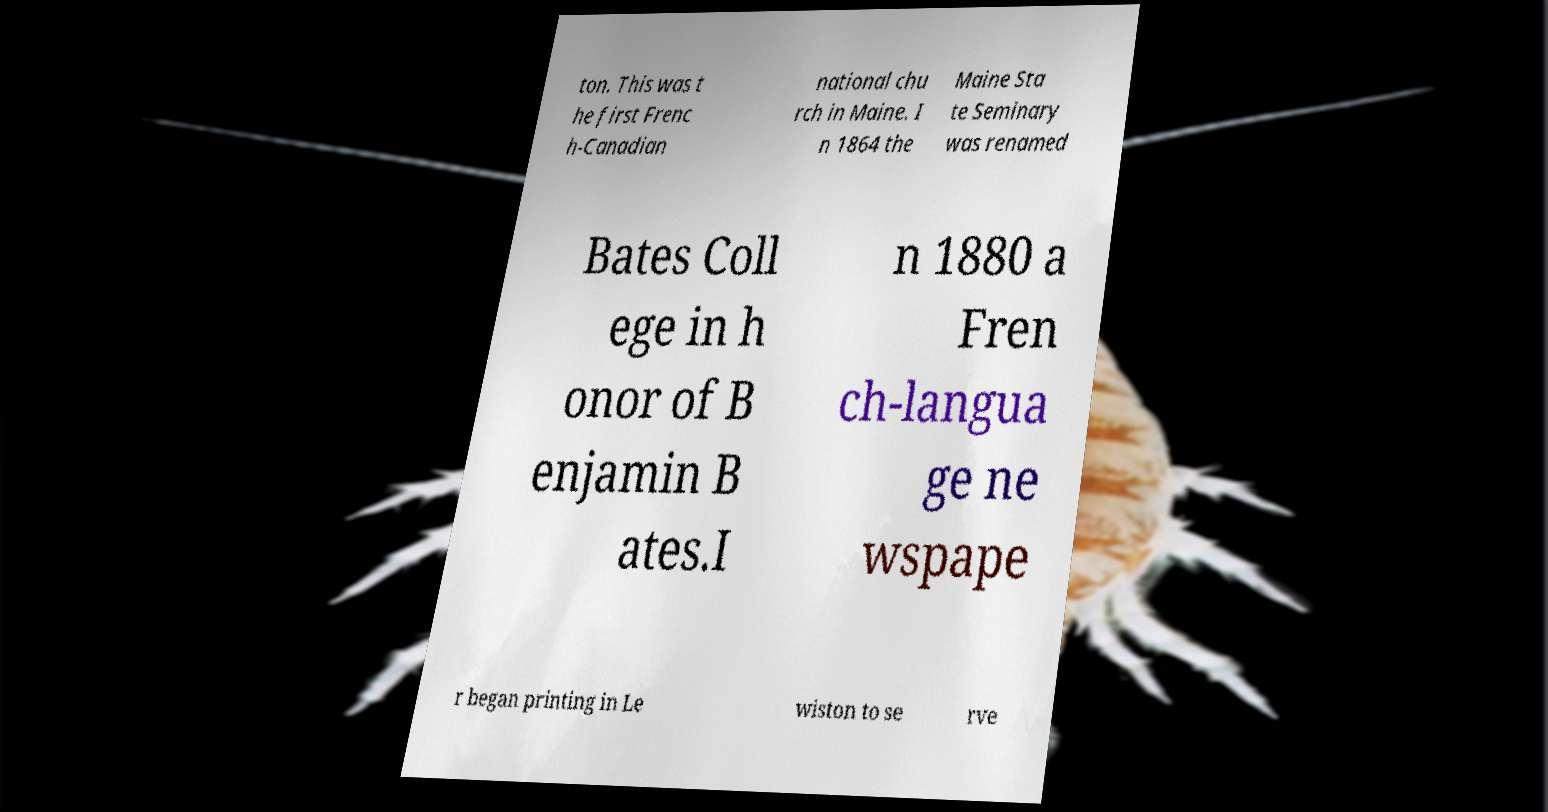For documentation purposes, I need the text within this image transcribed. Could you provide that? ton. This was t he first Frenc h-Canadian national chu rch in Maine. I n 1864 the Maine Sta te Seminary was renamed Bates Coll ege in h onor of B enjamin B ates.I n 1880 a Fren ch-langua ge ne wspape r began printing in Le wiston to se rve 